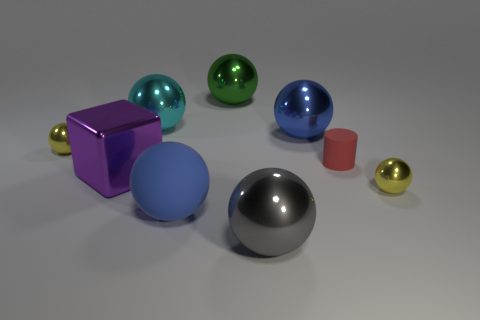Subtract all gray balls. How many balls are left? 6 Subtract all gray spheres. How many spheres are left? 6 Subtract all cylinders. How many objects are left? 8 Add 7 large purple metallic objects. How many large purple metallic objects are left? 8 Add 3 large gray balls. How many large gray balls exist? 4 Subtract 0 brown blocks. How many objects are left? 9 Subtract 1 blocks. How many blocks are left? 0 Subtract all brown cylinders. Subtract all purple balls. How many cylinders are left? 1 Subtract all yellow blocks. How many green balls are left? 1 Subtract all small blue metallic spheres. Subtract all small yellow balls. How many objects are left? 7 